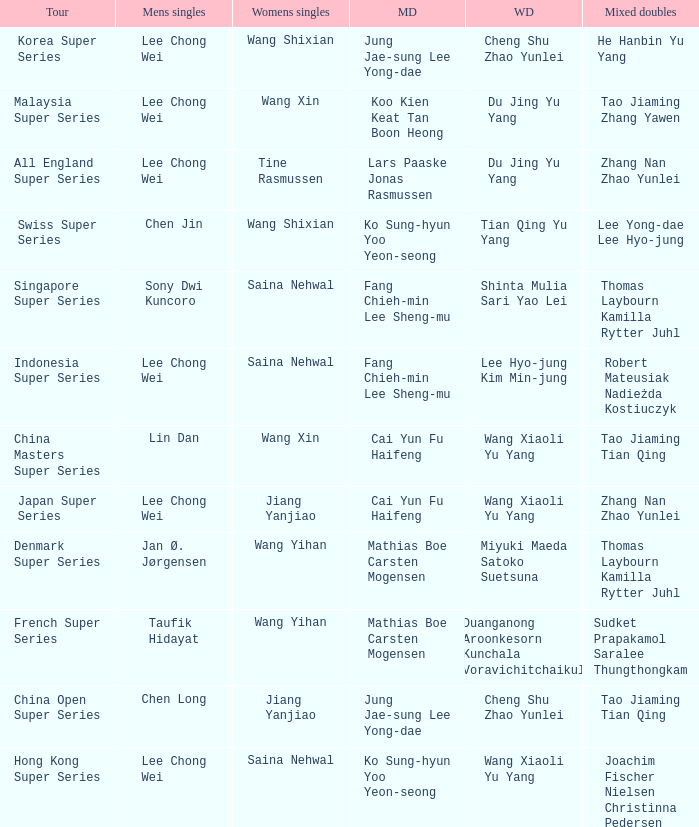Who is the women's doubles when the mixed doubles are sudket prapakamol saralee thungthongkam? Duanganong Aroonkesorn Kunchala Voravichitchaikul. 